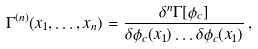Convert formula to latex. <formula><loc_0><loc_0><loc_500><loc_500>\Gamma ^ { ( n ) } ( x _ { 1 } , \dots , x _ { n } ) = \frac { \delta ^ { n } \Gamma [ \phi _ { c } ] } { \delta \phi _ { c } ( x _ { 1 } ) \dots \delta \phi _ { c } ( x _ { 1 } ) } \, ,</formula> 